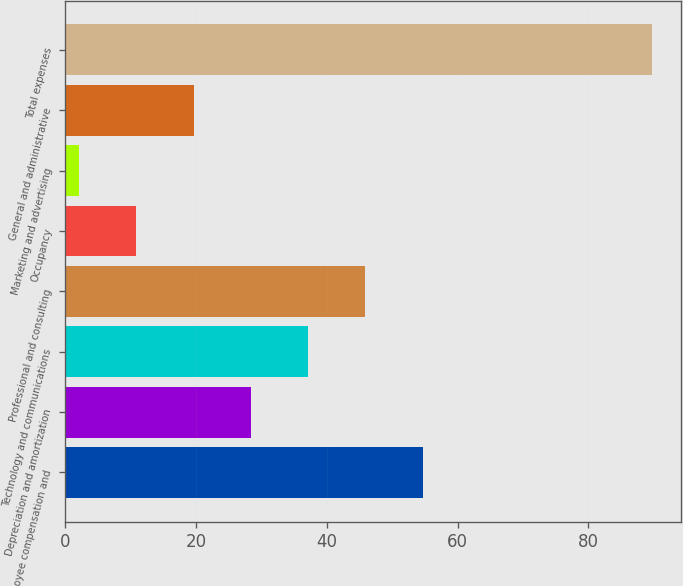Convert chart. <chart><loc_0><loc_0><loc_500><loc_500><bar_chart><fcel>Employee compensation and<fcel>Depreciation and amortization<fcel>Technology and communications<fcel>Professional and consulting<fcel>Occupancy<fcel>Marketing and advertising<fcel>General and administrative<fcel>Total expenses<nl><fcel>54.66<fcel>28.38<fcel>37.14<fcel>45.9<fcel>10.86<fcel>2.1<fcel>19.62<fcel>89.7<nl></chart> 